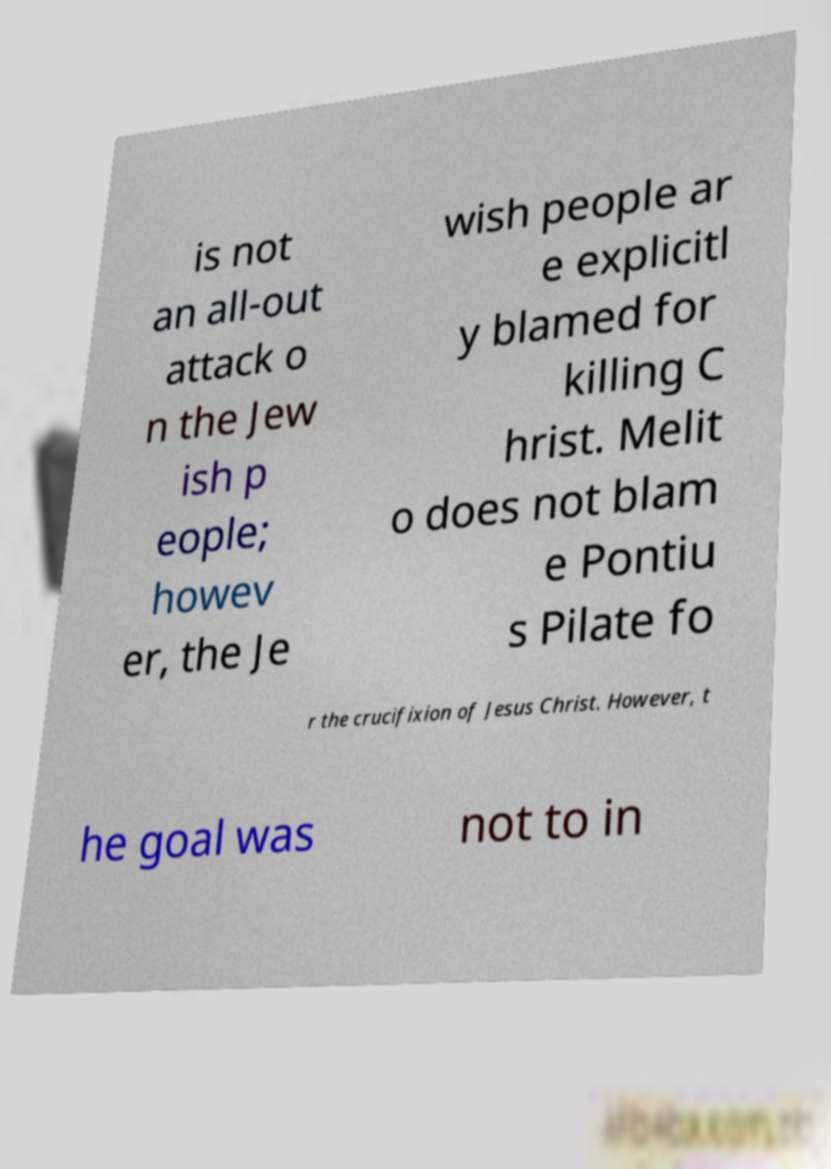For documentation purposes, I need the text within this image transcribed. Could you provide that? is not an all-out attack o n the Jew ish p eople; howev er, the Je wish people ar e explicitl y blamed for killing C hrist. Melit o does not blam e Pontiu s Pilate fo r the crucifixion of Jesus Christ. However, t he goal was not to in 